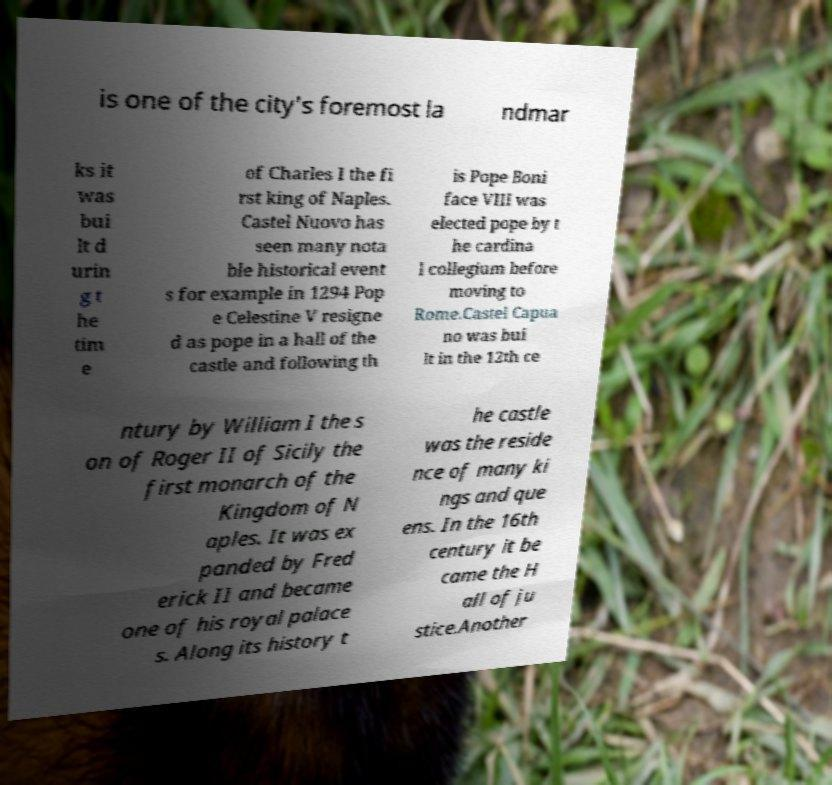Please read and relay the text visible in this image. What does it say? is one of the city's foremost la ndmar ks it was bui lt d urin g t he tim e of Charles I the fi rst king of Naples. Castel Nuovo has seen many nota ble historical event s for example in 1294 Pop e Celestine V resigne d as pope in a hall of the castle and following th is Pope Boni face VIII was elected pope by t he cardina l collegium before moving to Rome.Castel Capua no was bui lt in the 12th ce ntury by William I the s on of Roger II of Sicily the first monarch of the Kingdom of N aples. It was ex panded by Fred erick II and became one of his royal palace s. Along its history t he castle was the reside nce of many ki ngs and que ens. In the 16th century it be came the H all of ju stice.Another 